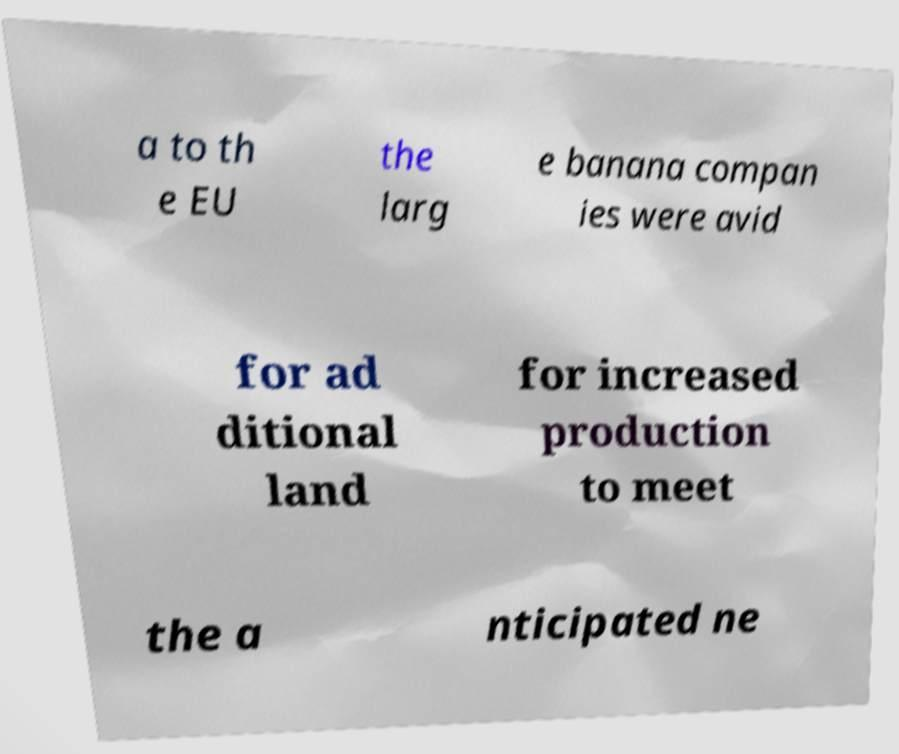Can you read and provide the text displayed in the image?This photo seems to have some interesting text. Can you extract and type it out for me? a to th e EU the larg e banana compan ies were avid for ad ditional land for increased production to meet the a nticipated ne 